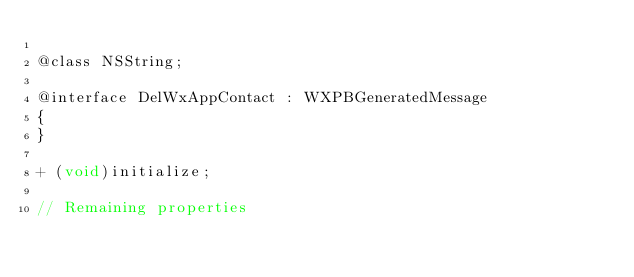<code> <loc_0><loc_0><loc_500><loc_500><_C_>
@class NSString;

@interface DelWxAppContact : WXPBGeneratedMessage
{
}

+ (void)initialize;

// Remaining properties</code> 